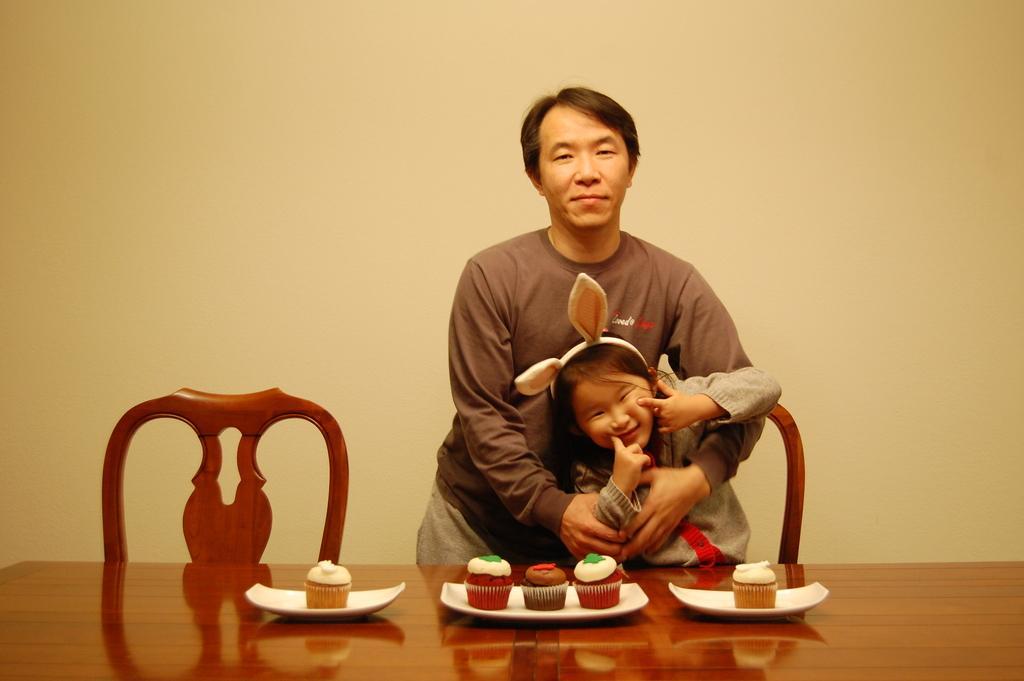Describe this image in one or two sentences. There is a room. There are two people in a room. In the center of the person is holding a baby. There is a table. There is a cup and cake cookies on a table. 